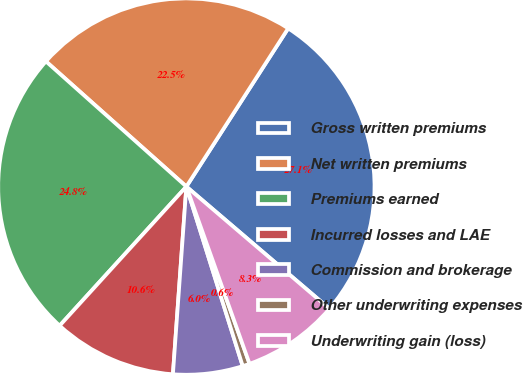Convert chart to OTSL. <chart><loc_0><loc_0><loc_500><loc_500><pie_chart><fcel>Gross written premiums<fcel>Net written premiums<fcel>Premiums earned<fcel>Incurred losses and LAE<fcel>Commission and brokerage<fcel>Other underwriting expenses<fcel>Underwriting gain (loss)<nl><fcel>27.15%<fcel>22.51%<fcel>24.83%<fcel>10.62%<fcel>5.98%<fcel>0.61%<fcel>8.3%<nl></chart> 